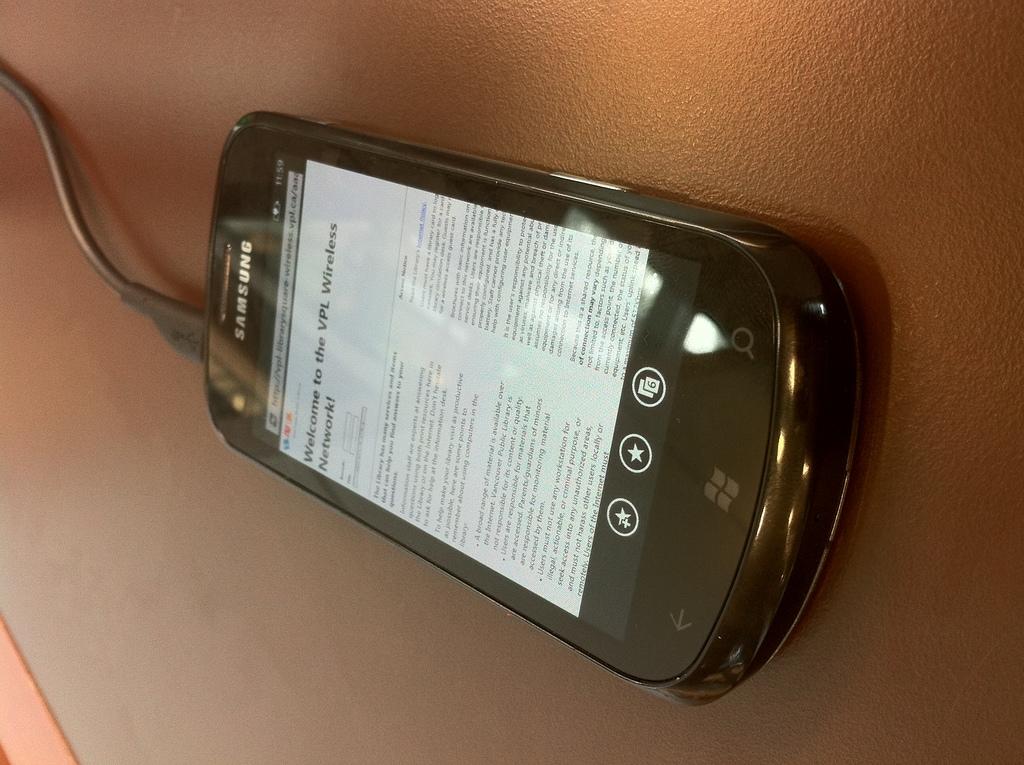What brand of phone is this?
Make the answer very short. Samsung. What type of network is mentioned?
Keep it short and to the point. Vpl wireless. 